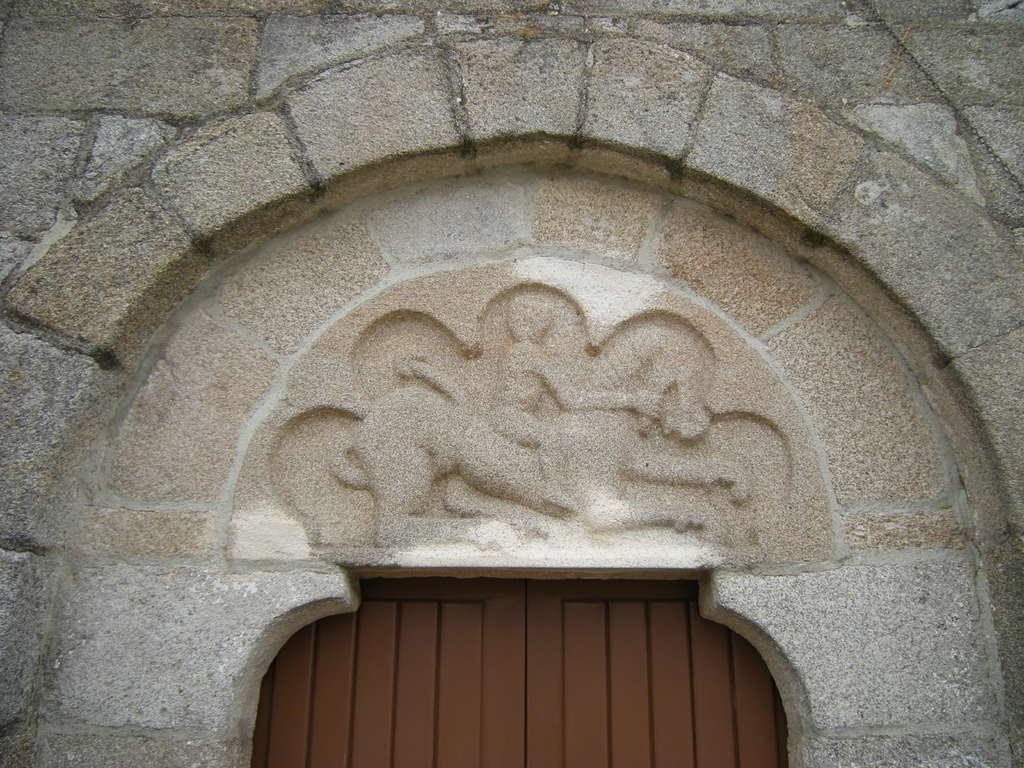What type of structure is visible in the image? There is a building wall in the image. What decorative elements can be seen on the building wall? There are sculptures in the image. Is there any entrance visible in the image? Yes, there is a door in the image. Can you determine the time of day when the image was taken? The image was likely taken during the day, as there is sufficient light to see the details. What type of wave can be seen crashing against the building wall in the image? There is no wave present in the image; it features a building wall with sculptures and a door. How many quinces are hanging from the sculptures in the image? There are no quinces present in the image; the sculptures are the main focus. 